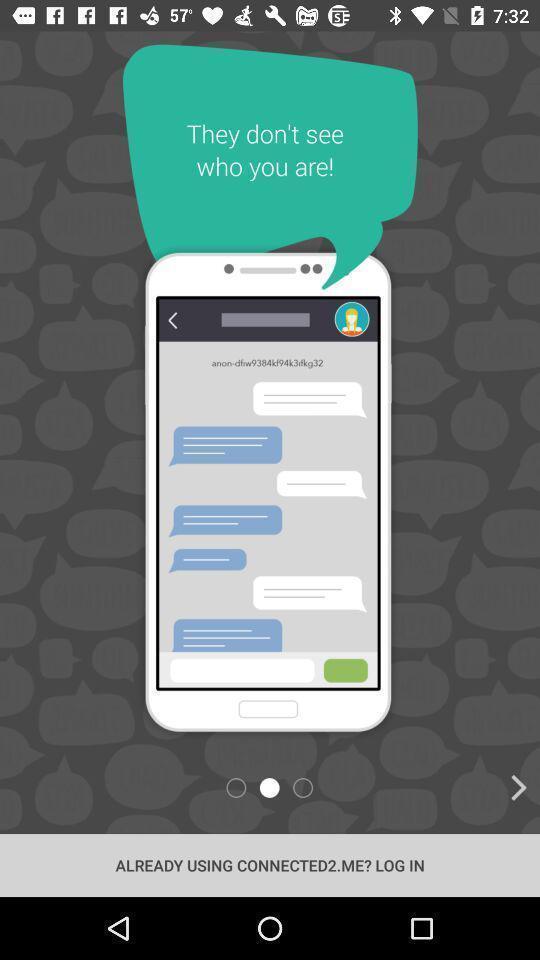What can you discern from this picture? Screen displaying demo instructions to access an application. 